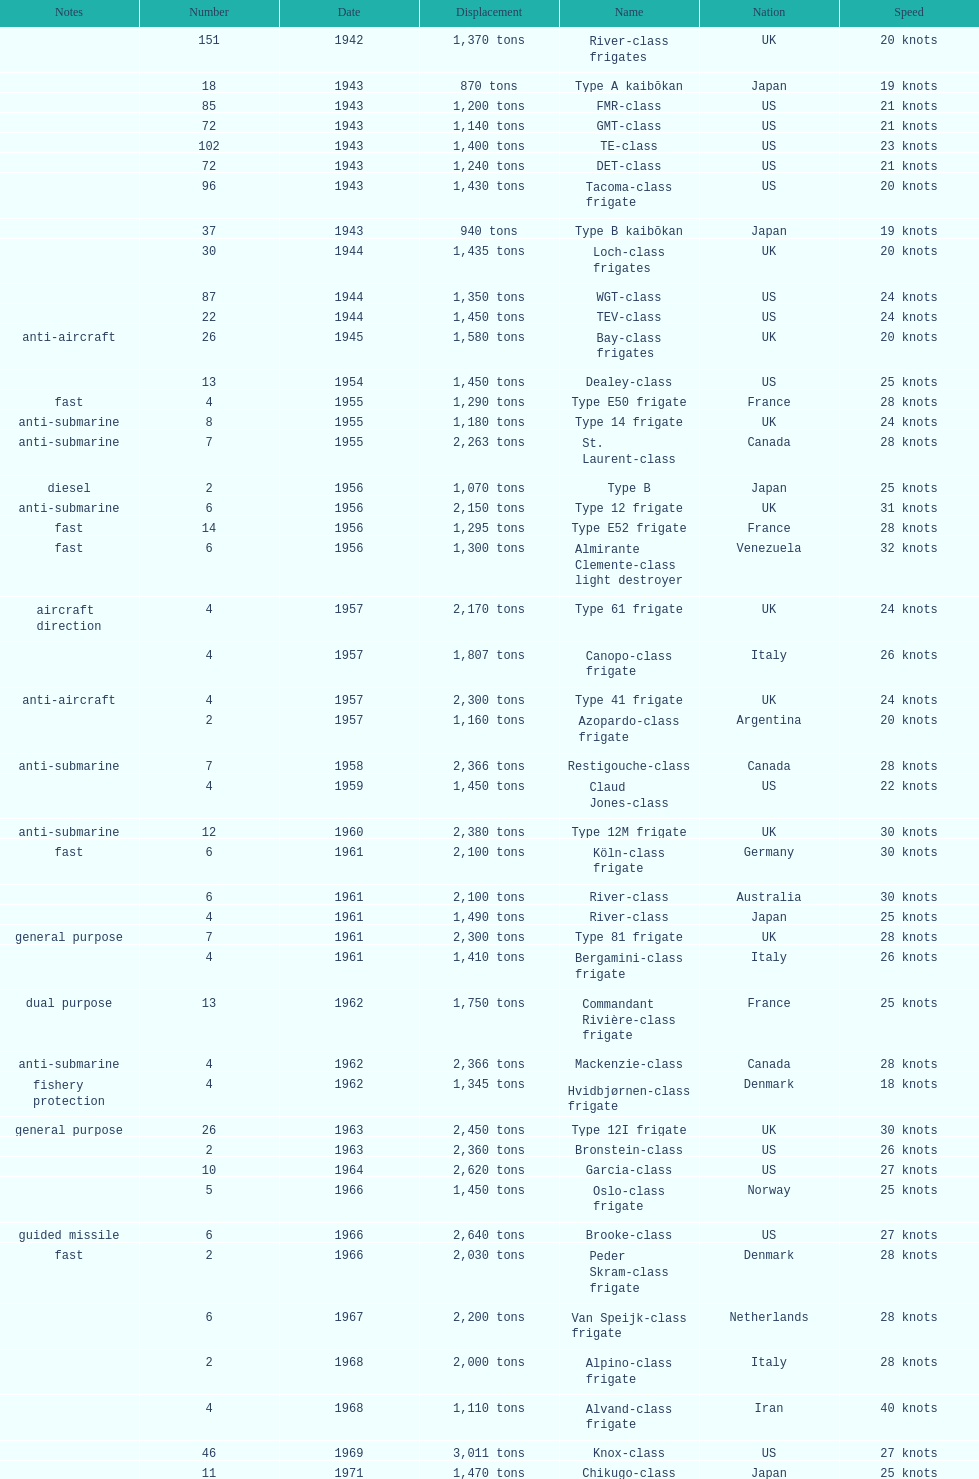How many tons of displacement does type b have? 940 tons. 